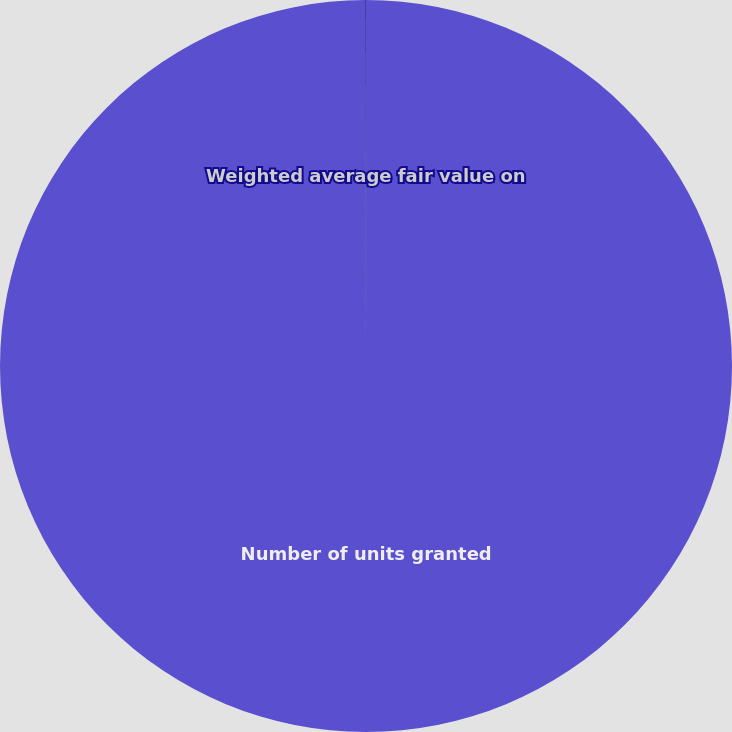Convert chart. <chart><loc_0><loc_0><loc_500><loc_500><pie_chart><fcel>Number of units granted<fcel>Weighted average fair value on<nl><fcel>99.97%<fcel>0.03%<nl></chart> 